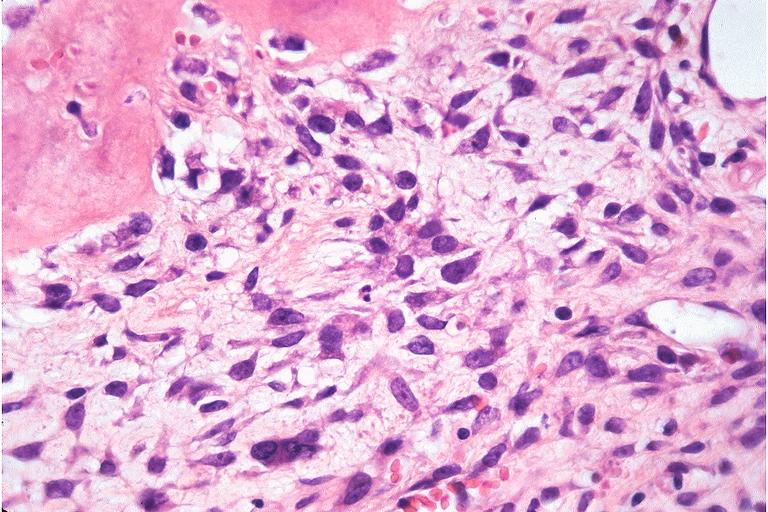does this image show osteosarcoma?
Answer the question using a single word or phrase. Yes 